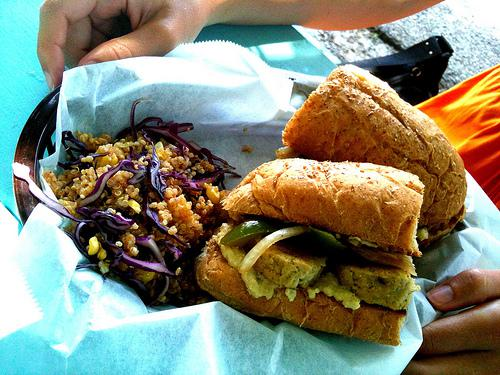Question: what is in the picture?
Choices:
A. Tables.
B. Chairs.
C. Food is in the picture.
D. Picture frames.
Answer with the letter. Answer: C Question: when did this picture take place?
Choices:
A. The morning time.
B. The afternoon.
C. Around midnight.
D. It took place in the day time.
Answer with the letter. Answer: D Question: what is the food?
Choices:
A. The food is a sandwich and some salad.
B. The food is beef and noodles.
C. The food is rice pilaf.
D. The food is a Hamburger and fries.
Answer with the letter. Answer: A Question: why did this picture get taken?
Choices:
A. To show the weather.
B. To show how many clouds are in the sky.
C. To show the food in the picture.
D. To show how many animals are in the zoo.
Answer with the letter. Answer: C Question: what color is the napkin under the food?
Choices:
A. White.
B. Tan.
C. The napkin is blue.
D. Yellow.
Answer with the letter. Answer: C 